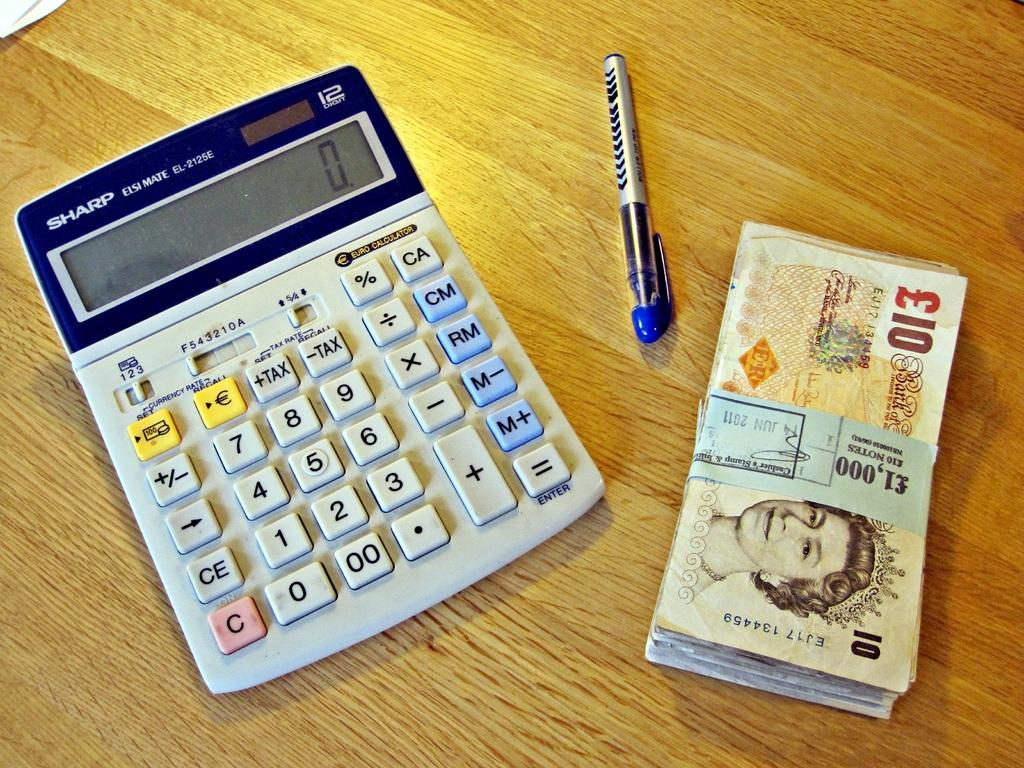<image>
Give a short and clear explanation of the subsequent image. A calculator, manufactured by Sharp, has an LCD screen that reads 0. 